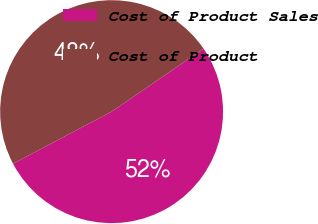Convert chart. <chart><loc_0><loc_0><loc_500><loc_500><pie_chart><fcel>Cost of Product Sales<fcel>Cost of Product<nl><fcel>51.83%<fcel>48.17%<nl></chart> 